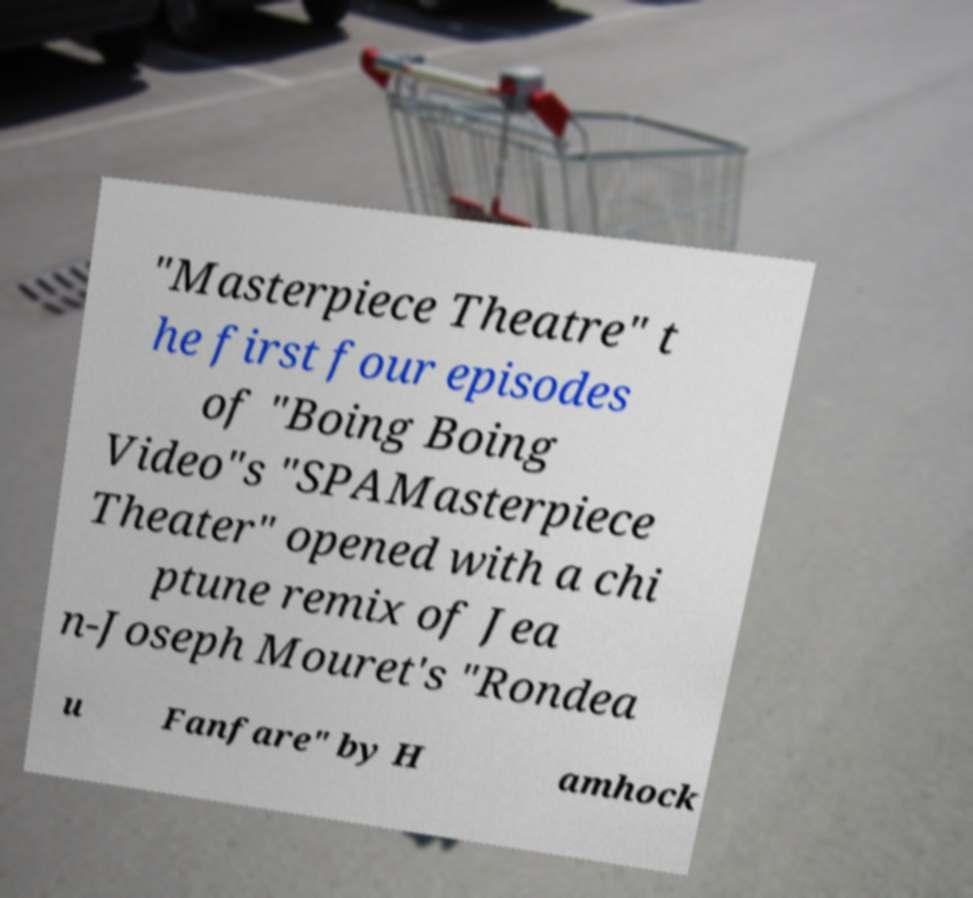Can you read and provide the text displayed in the image?This photo seems to have some interesting text. Can you extract and type it out for me? "Masterpiece Theatre" t he first four episodes of "Boing Boing Video"s "SPAMasterpiece Theater" opened with a chi ptune remix of Jea n-Joseph Mouret's "Rondea u Fanfare" by H amhock 